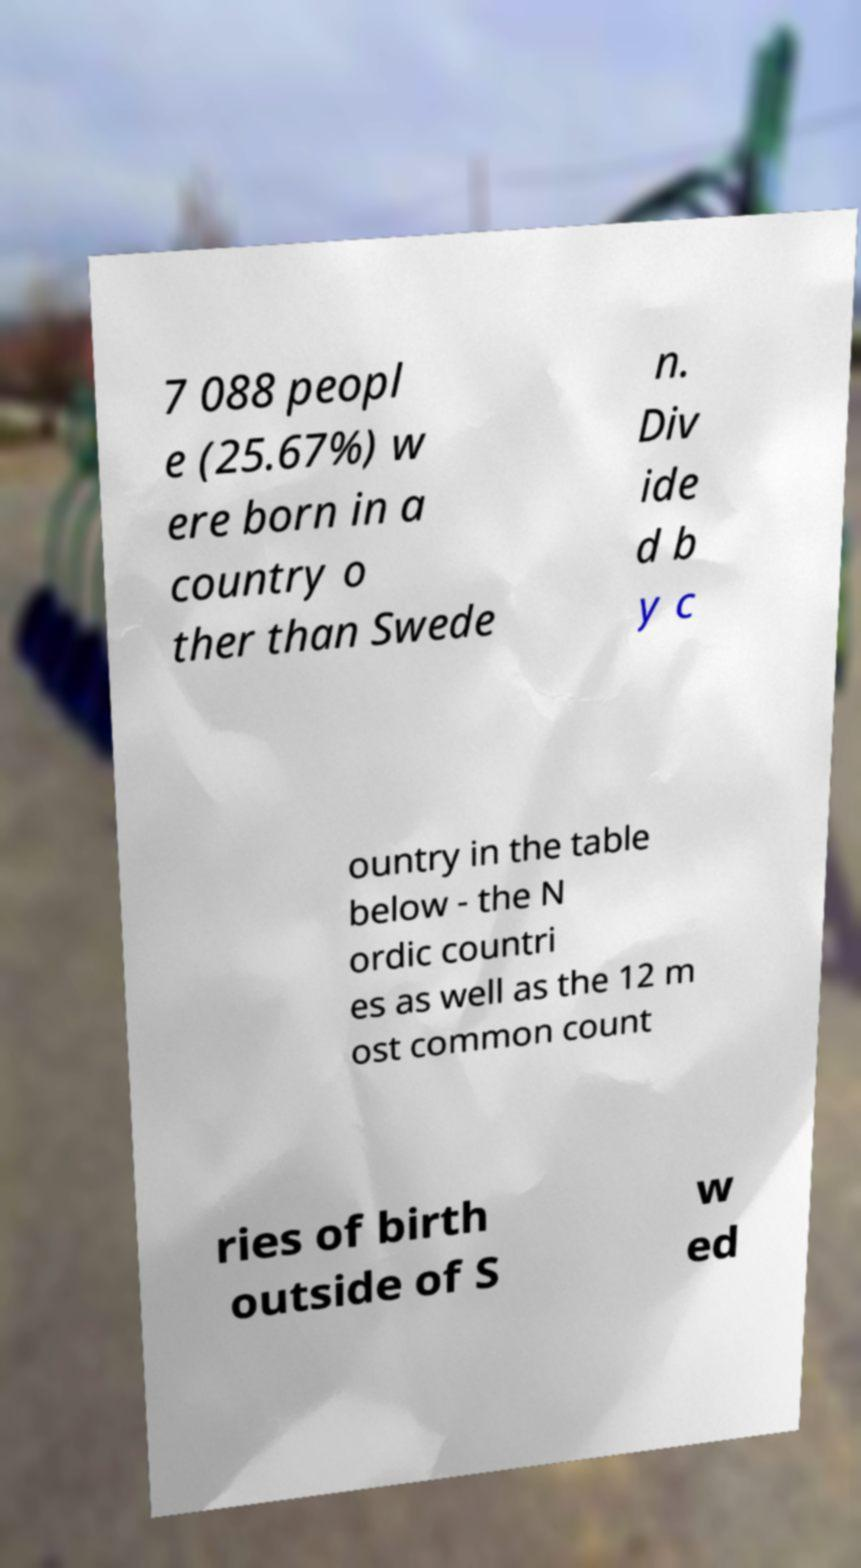Please identify and transcribe the text found in this image. 7 088 peopl e (25.67%) w ere born in a country o ther than Swede n. Div ide d b y c ountry in the table below - the N ordic countri es as well as the 12 m ost common count ries of birth outside of S w ed 